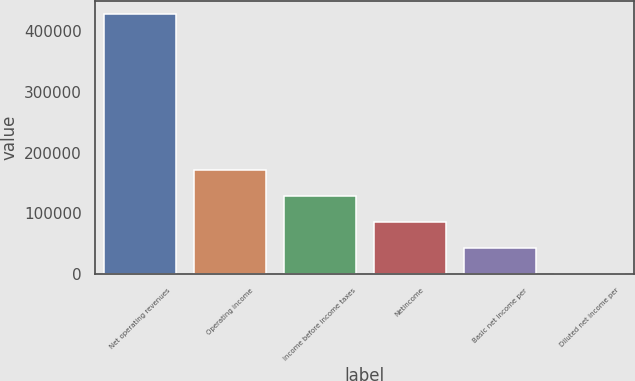<chart> <loc_0><loc_0><loc_500><loc_500><bar_chart><fcel>Net operating revenues<fcel>Operating income<fcel>Income before income taxes<fcel>Netincome<fcel>Basic net income per<fcel>Diluted net income per<nl><fcel>427665<fcel>171066<fcel>128300<fcel>85533.3<fcel>42766.9<fcel>0.4<nl></chart> 